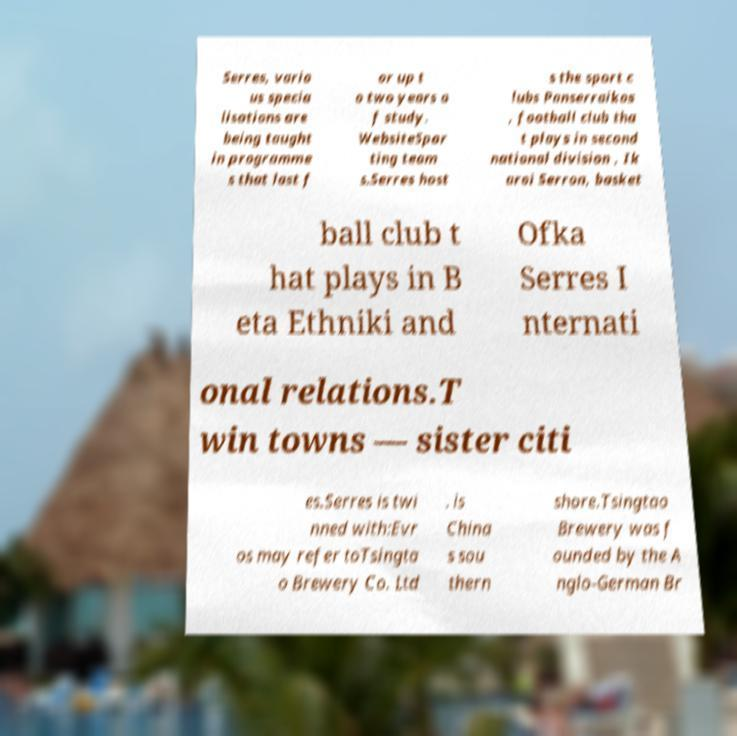Please identify and transcribe the text found in this image. Serres, vario us specia lisations are being taught in programme s that last f or up t o two years o f study. WebsiteSpor ting team s.Serres host s the sport c lubs Panserraikos , football club tha t plays in second national division , Ik aroi Serron, basket ball club t hat plays in B eta Ethniki and Ofka Serres I nternati onal relations.T win towns — sister citi es.Serres is twi nned with:Evr os may refer toTsingta o Brewery Co. Ltd . is China s sou thern shore.Tsingtao Brewery was f ounded by the A nglo-German Br 